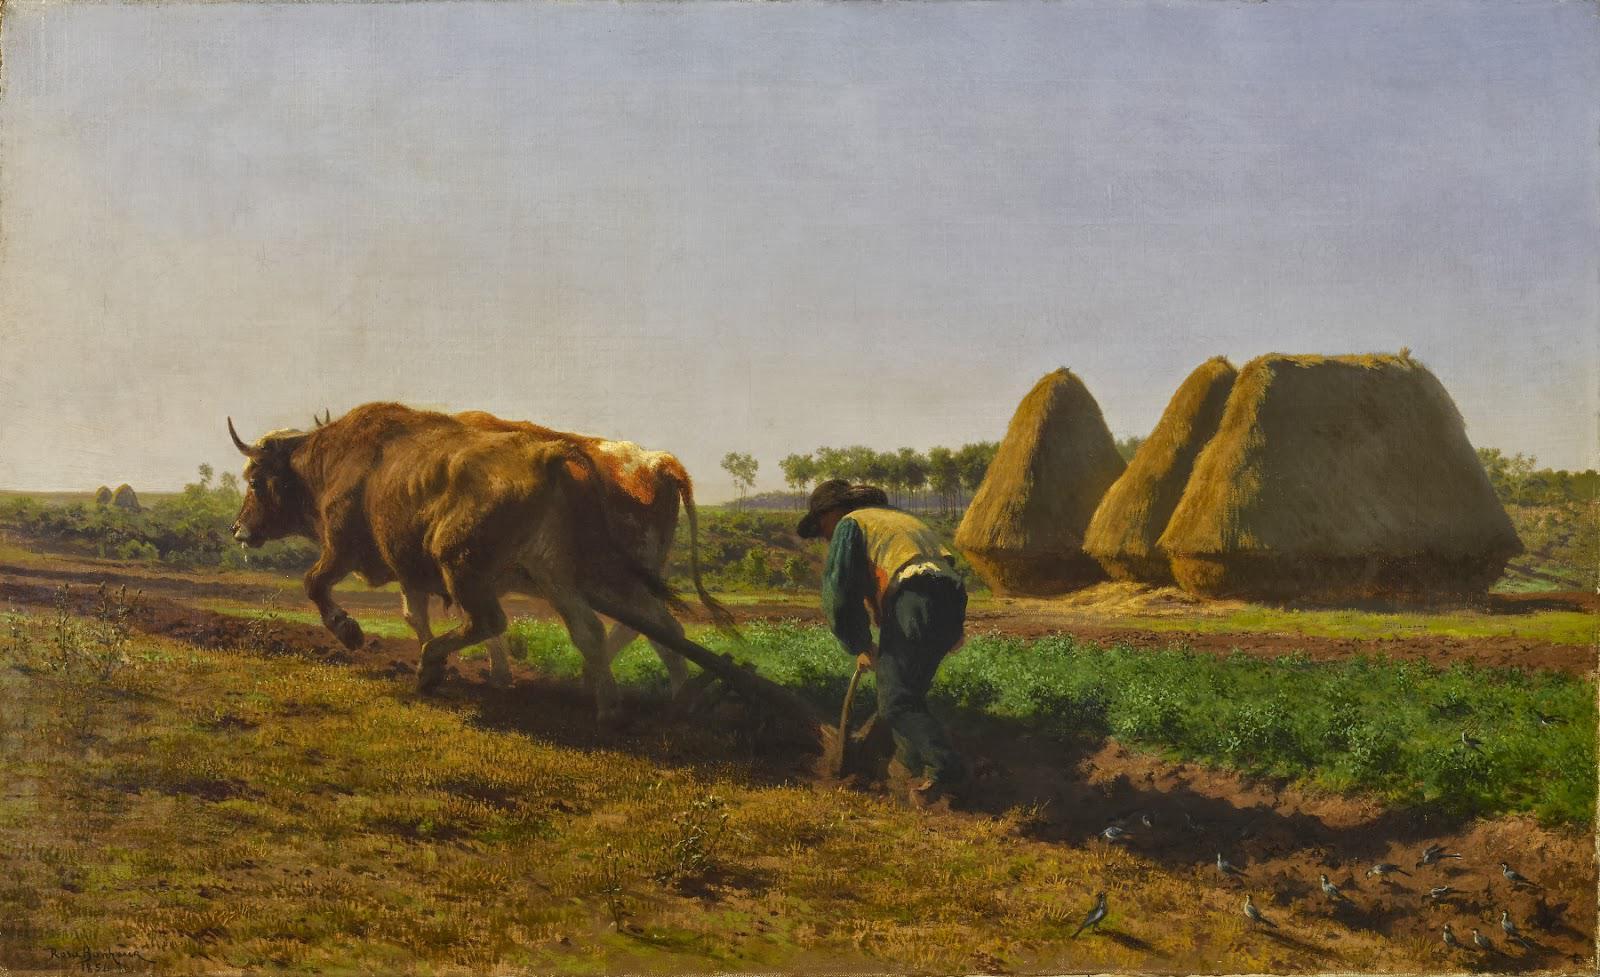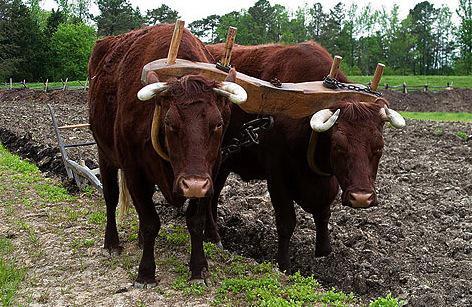The first image is the image on the left, the second image is the image on the right. Assess this claim about the two images: "One image shows two brown cattle wearing a wooden plow hitch and angled rightward, and the other image shows a person standing behind a team of two cattle.". Correct or not? Answer yes or no. Yes. The first image is the image on the left, the second image is the image on the right. For the images displayed, is the sentence "Both images show cows plowing a field." factually correct? Answer yes or no. Yes. 